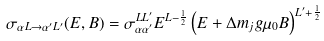Convert formula to latex. <formula><loc_0><loc_0><loc_500><loc_500>\sigma _ { \alpha L \rightarrow \alpha ^ { \prime } L ^ { \prime } } ( E , B ) = \sigma _ { \alpha \alpha ^ { \prime } } ^ { L L ^ { \prime } } E ^ { L - \frac { 1 } { 2 } } \left ( E + \Delta m _ { j } g \mu _ { 0 } B \right ) ^ { L ^ { \prime } + \frac { 1 } { 2 } }</formula> 